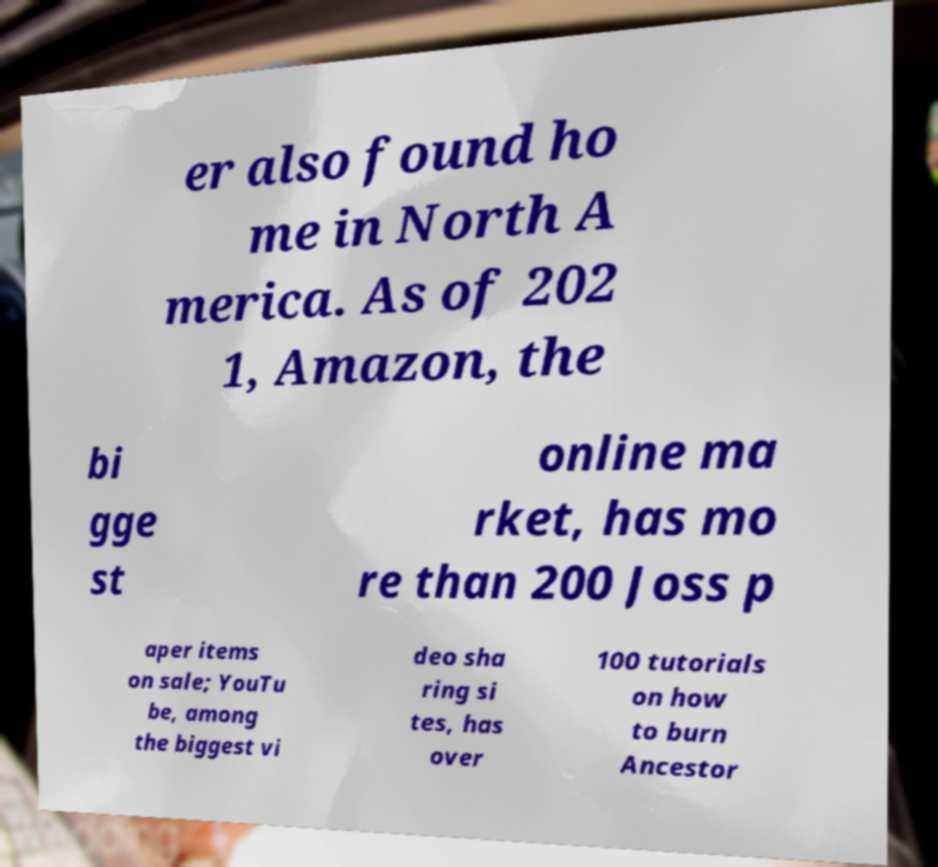Could you extract and type out the text from this image? er also found ho me in North A merica. As of 202 1, Amazon, the bi gge st online ma rket, has mo re than 200 Joss p aper items on sale; YouTu be, among the biggest vi deo sha ring si tes, has over 100 tutorials on how to burn Ancestor 